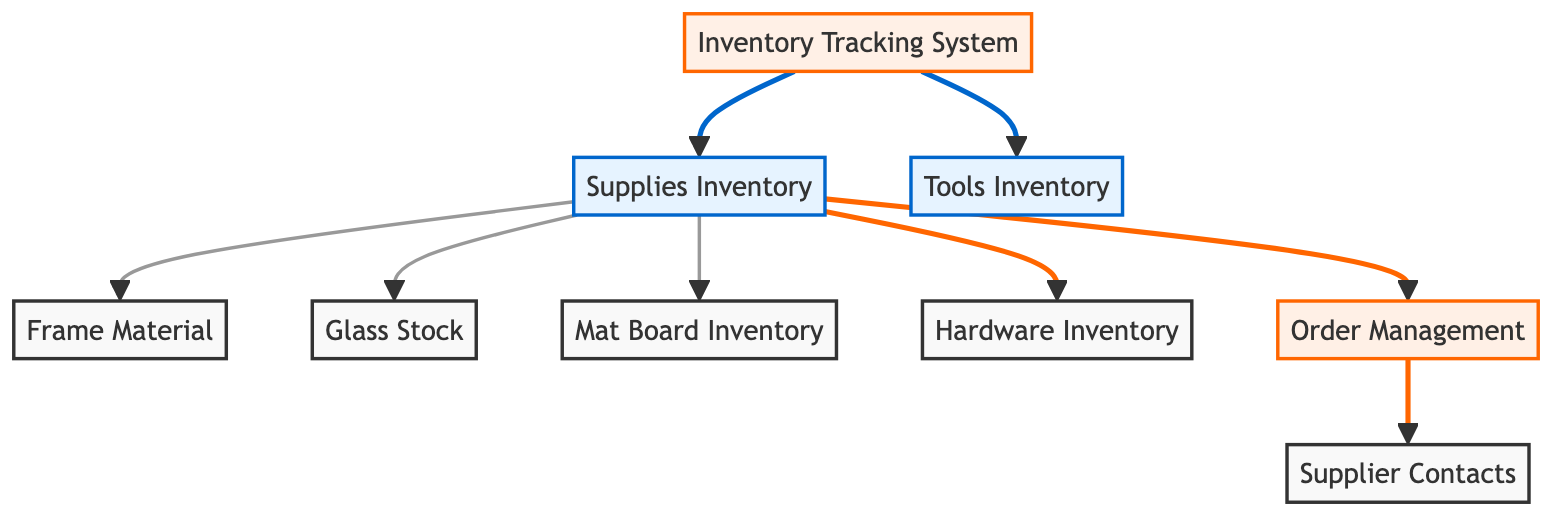What is the total number of nodes in the diagram? The diagram lists the following nodes: Supplies Inventory, Tools Inventory, Frame Material, Glass Stock, Mat Board Inventory, Hardware Inventory, Order Management, Supplier Contacts, and Inventory Tracking System. Counting these gives a total of 9 nodes.
Answer: 9 Which node is connected to the Order Management node? The Order Management node has a connection directed to the Supplier Contacts node, indicating that it is related to supplier information.
Answer: Supplier Contacts How many edges are there in the diagram? The edges described in the diagram indicate the relationships and connections between different nodes. Counting these edges gives a total of 8 edges in the diagram.
Answer: 8 What is the relationship between Supplies Inventory and Inventory Tracking System? The Supplies Inventory node is connected to the Inventory Tracking System node, indicating that the inventory tracking is dependent on the supplies available in the shop.
Answer: Inventory Tracking System Which two nodes connect to Tools Inventory? According to the diagram, there is no direct edge leading to or from the Tools Inventory node beyond being a separate inventory, indicating no connected relationships shown in the current structure.
Answer: None What does the connection from Supplies Inventory to Order Management imply? The directed edge from Supplies Inventory to Order Management implies that the inventory of supplies informs the order management process, reflecting that ordering is based on current supplies.
Answer: Order Management Which node has the highest degree of connections (edges) in the diagram? Analyzing the edges, the Supplies Inventory node has the highest degree of connections as it connects to Frame Material, Glass Stock, Mat Board Inventory, Hardware Inventory, and Order Management, amounting to 5 connections.
Answer: Supplies Inventory Who are the suppliers referred to in the diagram? The Supplier Contacts node directly connected to the Order Management node implies that the suppliers referred to are the ones associated with the orders managed within the shop's inventory system.
Answer: Supplier Contacts 